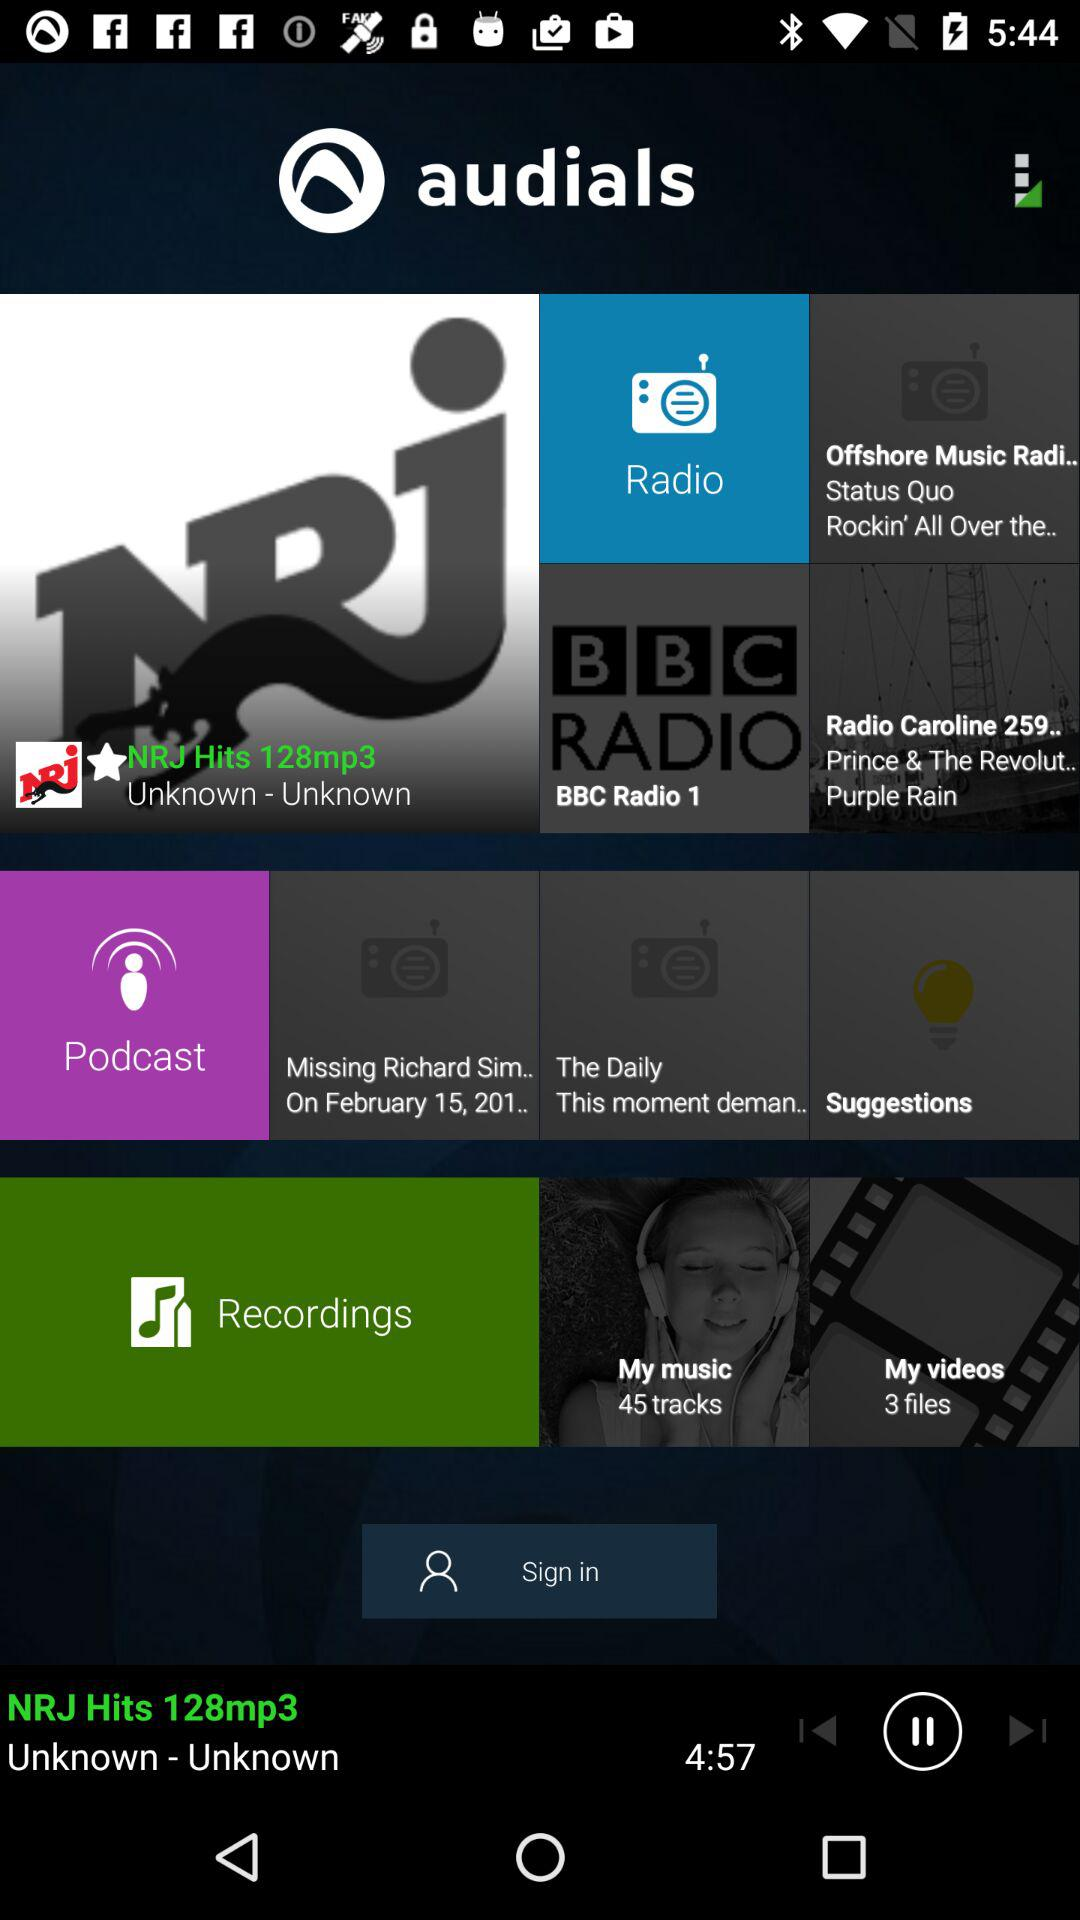What is the application name? The application name is "audials". 